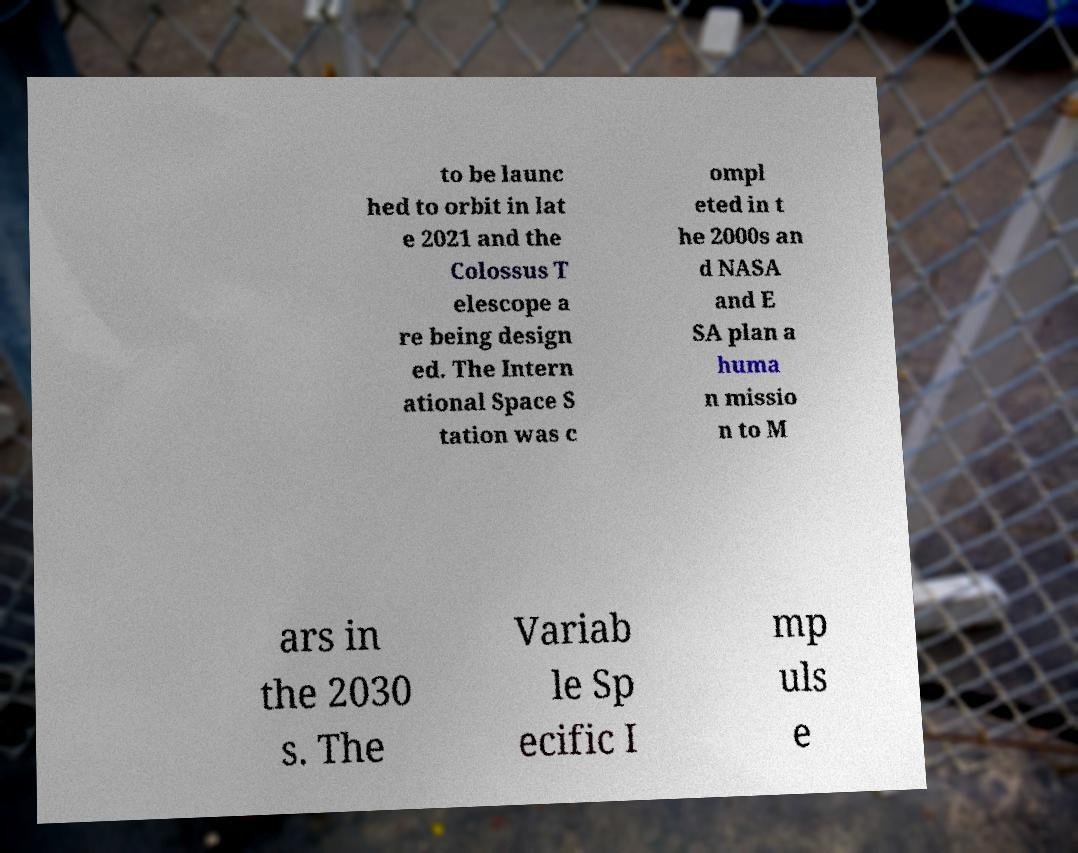Please read and relay the text visible in this image. What does it say? to be launc hed to orbit in lat e 2021 and the Colossus T elescope a re being design ed. The Intern ational Space S tation was c ompl eted in t he 2000s an d NASA and E SA plan a huma n missio n to M ars in the 2030 s. The Variab le Sp ecific I mp uls e 